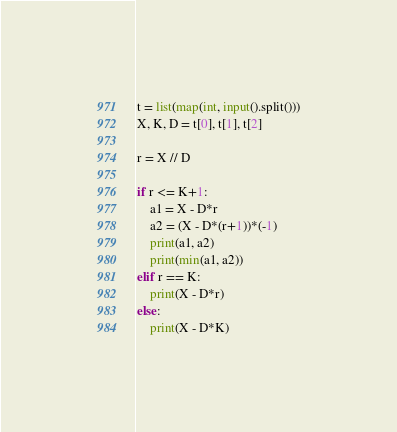<code> <loc_0><loc_0><loc_500><loc_500><_Python_>t = list(map(int, input().split()))
X, K, D = t[0], t[1], t[2]

r = X // D

if r <= K+1:
    a1 = X - D*r
    a2 = (X - D*(r+1))*(-1)
    print(a1, a2)
    print(min(a1, a2))
elif r == K:
    print(X - D*r)
else:
    print(X - D*K)

</code> 